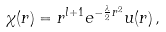<formula> <loc_0><loc_0><loc_500><loc_500>\chi ( r ) = r ^ { l + 1 } e ^ { - \frac { \lambda } { 2 } r ^ { 2 } } u ( r ) \, ,</formula> 